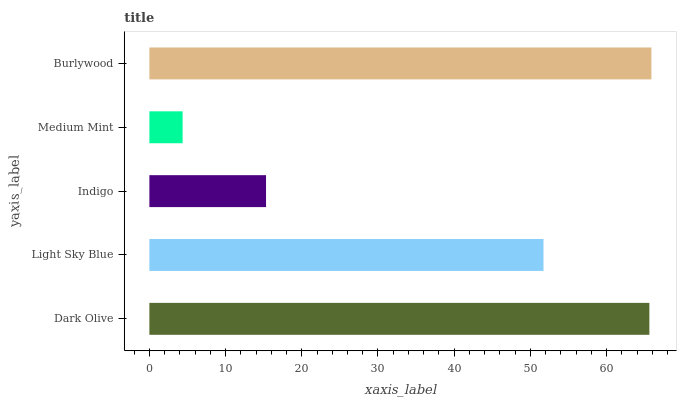Is Medium Mint the minimum?
Answer yes or no. Yes. Is Burlywood the maximum?
Answer yes or no. Yes. Is Light Sky Blue the minimum?
Answer yes or no. No. Is Light Sky Blue the maximum?
Answer yes or no. No. Is Dark Olive greater than Light Sky Blue?
Answer yes or no. Yes. Is Light Sky Blue less than Dark Olive?
Answer yes or no. Yes. Is Light Sky Blue greater than Dark Olive?
Answer yes or no. No. Is Dark Olive less than Light Sky Blue?
Answer yes or no. No. Is Light Sky Blue the high median?
Answer yes or no. Yes. Is Light Sky Blue the low median?
Answer yes or no. Yes. Is Dark Olive the high median?
Answer yes or no. No. Is Medium Mint the low median?
Answer yes or no. No. 